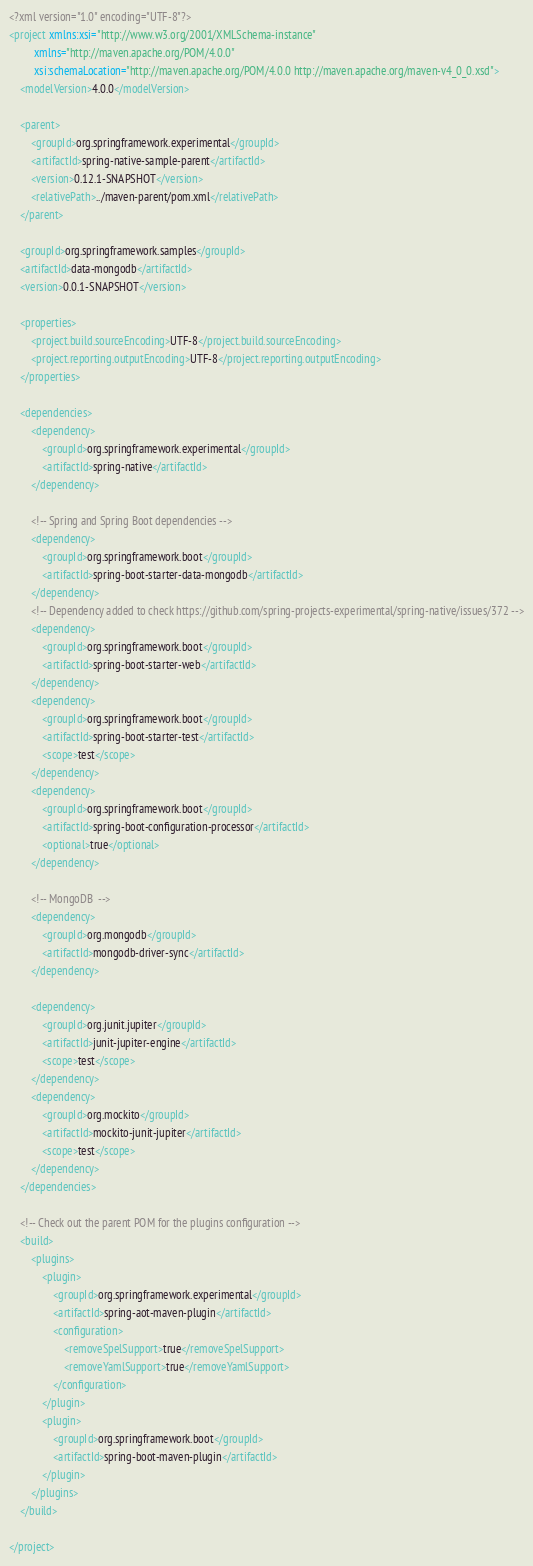Convert code to text. <code><loc_0><loc_0><loc_500><loc_500><_XML_><?xml version="1.0" encoding="UTF-8"?>
<project xmlns:xsi="http://www.w3.org/2001/XMLSchema-instance"
		 xmlns="http://maven.apache.org/POM/4.0.0"
		 xsi:schemaLocation="http://maven.apache.org/POM/4.0.0 http://maven.apache.org/maven-v4_0_0.xsd">
	<modelVersion>4.0.0</modelVersion>

	<parent>
		<groupId>org.springframework.experimental</groupId>
		<artifactId>spring-native-sample-parent</artifactId>
		<version>0.12.1-SNAPSHOT</version>
		<relativePath>../maven-parent/pom.xml</relativePath>
	</parent>

	<groupId>org.springframework.samples</groupId>
	<artifactId>data-mongodb</artifactId>
	<version>0.0.1-SNAPSHOT</version>

	<properties>
		<project.build.sourceEncoding>UTF-8</project.build.sourceEncoding>
		<project.reporting.outputEncoding>UTF-8</project.reporting.outputEncoding>
	</properties>

	<dependencies>
		<dependency>
			<groupId>org.springframework.experimental</groupId>
			<artifactId>spring-native</artifactId>
		</dependency>

		<!-- Spring and Spring Boot dependencies -->
		<dependency>
			<groupId>org.springframework.boot</groupId>
			<artifactId>spring-boot-starter-data-mongodb</artifactId>
		</dependency>
		<!-- Dependency added to check https://github.com/spring-projects-experimental/spring-native/issues/372 -->
		<dependency>
			<groupId>org.springframework.boot</groupId>
			<artifactId>spring-boot-starter-web</artifactId>
		</dependency>
		<dependency>
			<groupId>org.springframework.boot</groupId>
			<artifactId>spring-boot-starter-test</artifactId>
			<scope>test</scope>
		</dependency>
		<dependency>
			<groupId>org.springframework.boot</groupId>
			<artifactId>spring-boot-configuration-processor</artifactId>
			<optional>true</optional>
		</dependency>

		<!-- MongoDB  -->
		<dependency>
			<groupId>org.mongodb</groupId>
			<artifactId>mongodb-driver-sync</artifactId>
		</dependency>

		<dependency>
			<groupId>org.junit.jupiter</groupId>
			<artifactId>junit-jupiter-engine</artifactId>
			<scope>test</scope>
		</dependency>
		<dependency>
			<groupId>org.mockito</groupId>
			<artifactId>mockito-junit-jupiter</artifactId>
			<scope>test</scope>
		</dependency>
	</dependencies>

	<!-- Check out the parent POM for the plugins configuration -->
	<build>
		<plugins>
			<plugin>
				<groupId>org.springframework.experimental</groupId>
				<artifactId>spring-aot-maven-plugin</artifactId>
				<configuration>
					<removeSpelSupport>true</removeSpelSupport>
					<removeYamlSupport>true</removeYamlSupport>
				</configuration>
			</plugin>
			<plugin>
				<groupId>org.springframework.boot</groupId>
				<artifactId>spring-boot-maven-plugin</artifactId>
			</plugin>
		</plugins>
	</build>

</project>
</code> 